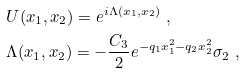<formula> <loc_0><loc_0><loc_500><loc_500>& U ( x _ { 1 } , x _ { 2 } ) = e ^ { i \Lambda ( x _ { 1 } , x _ { 2 } ) } \ , \\ & \Lambda ( x _ { 1 } , x _ { 2 } ) = - \frac { C _ { 3 } } { 2 } e ^ { - q _ { 1 } x _ { 1 } ^ { 2 } - q _ { 2 } x _ { 2 } ^ { 2 } } \sigma _ { 2 } \ ,</formula> 